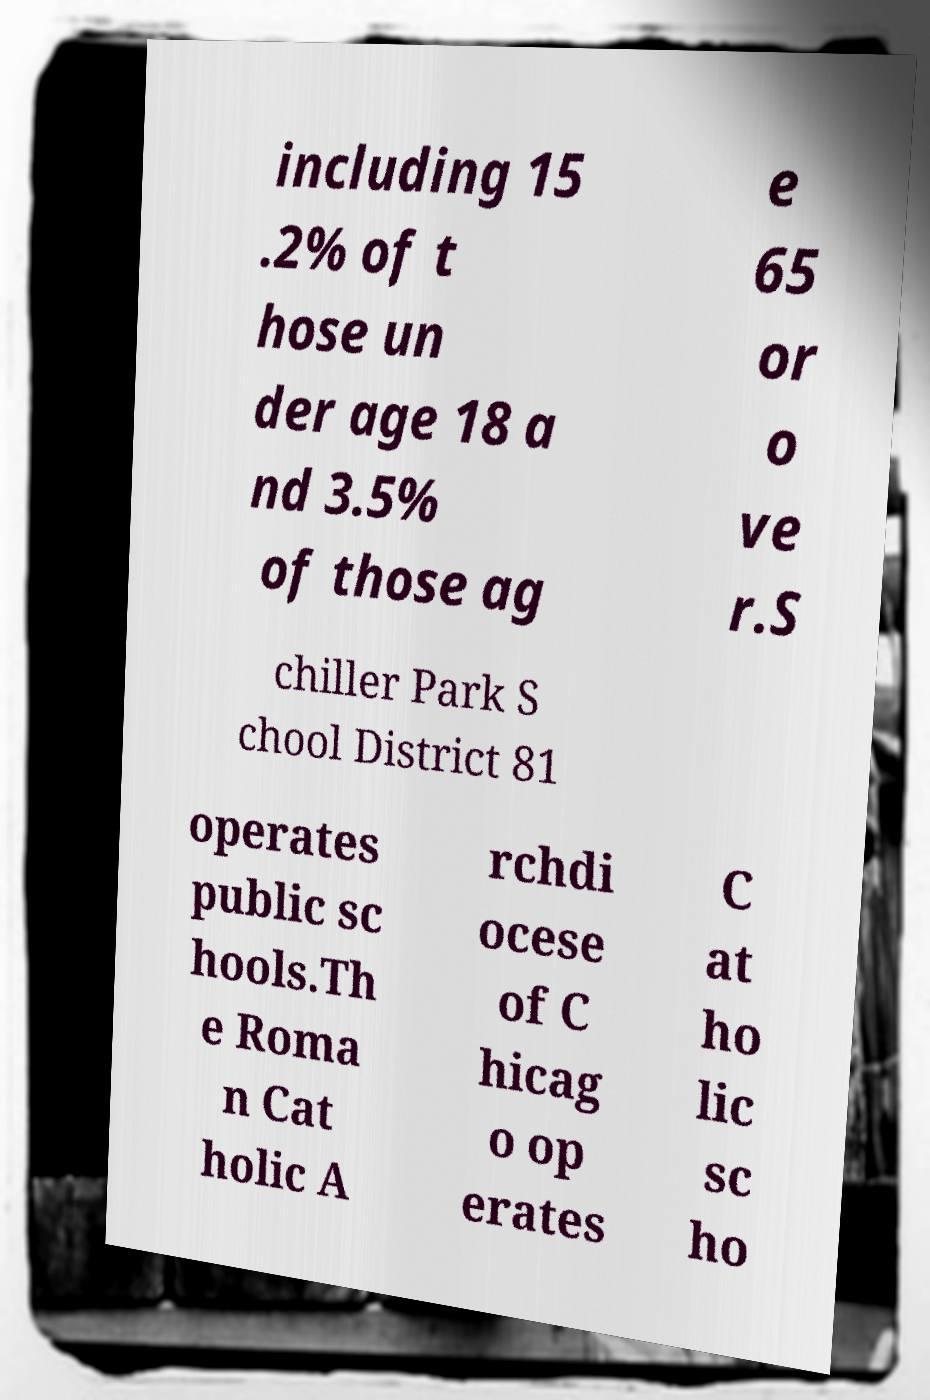What messages or text are displayed in this image? I need them in a readable, typed format. including 15 .2% of t hose un der age 18 a nd 3.5% of those ag e 65 or o ve r.S chiller Park S chool District 81 operates public sc hools.Th e Roma n Cat holic A rchdi ocese of C hicag o op erates C at ho lic sc ho 